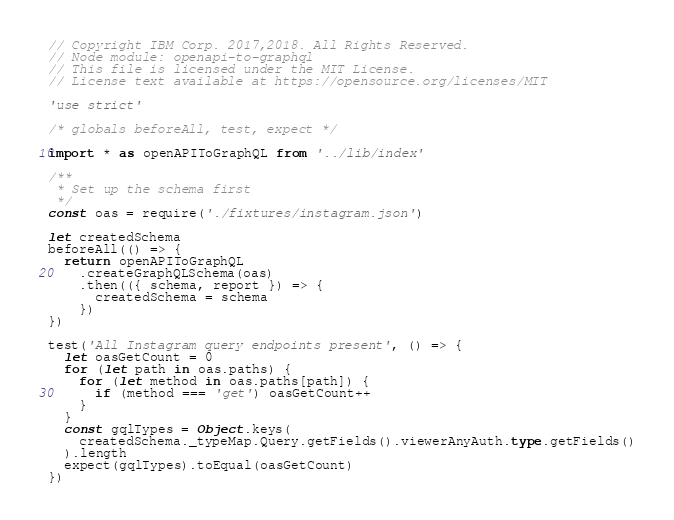Convert code to text. <code><loc_0><loc_0><loc_500><loc_500><_TypeScript_>// Copyright IBM Corp. 2017,2018. All Rights Reserved.
// Node module: openapi-to-graphql
// This file is licensed under the MIT License.
// License text available at https://opensource.org/licenses/MIT

'use strict'

/* globals beforeAll, test, expect */

import * as openAPIToGraphQL from '../lib/index'

/**
 * Set up the schema first
 */
const oas = require('./fixtures/instagram.json')

let createdSchema
beforeAll(() => {
  return openAPIToGraphQL
    .createGraphQLSchema(oas)
    .then(({ schema, report }) => {
      createdSchema = schema
    })
})

test('All Instagram query endpoints present', () => {
  let oasGetCount = 0
  for (let path in oas.paths) {
    for (let method in oas.paths[path]) {
      if (method === 'get') oasGetCount++
    }
  }
  const gqlTypes = Object.keys(
    createdSchema._typeMap.Query.getFields().viewerAnyAuth.type.getFields()
  ).length
  expect(gqlTypes).toEqual(oasGetCount)
})
</code> 